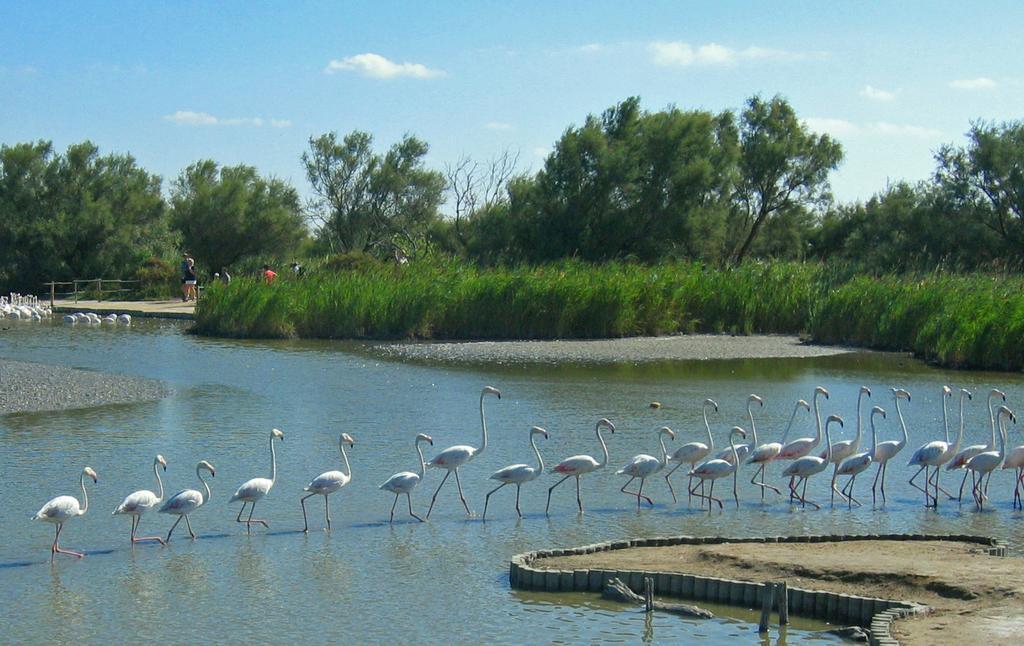Describe this image in one or two sentences. In this image we can see there are many ducks walking one after the other, at the back there are many trees and the background is the sky. 